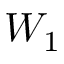Convert formula to latex. <formula><loc_0><loc_0><loc_500><loc_500>W _ { 1 }</formula> 